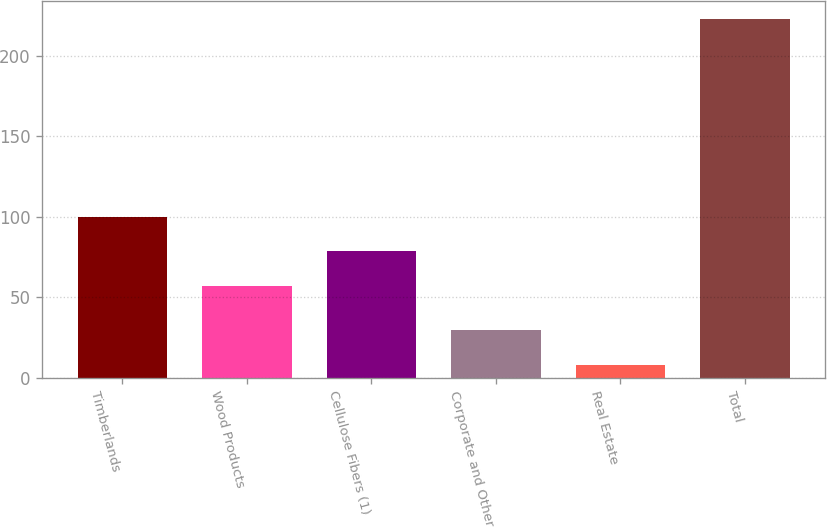<chart> <loc_0><loc_0><loc_500><loc_500><bar_chart><fcel>Timberlands<fcel>Wood Products<fcel>Cellulose Fibers (1)<fcel>Corporate and Other<fcel>Real Estate<fcel>Total<nl><fcel>100<fcel>57<fcel>78.5<fcel>29.5<fcel>8<fcel>223<nl></chart> 